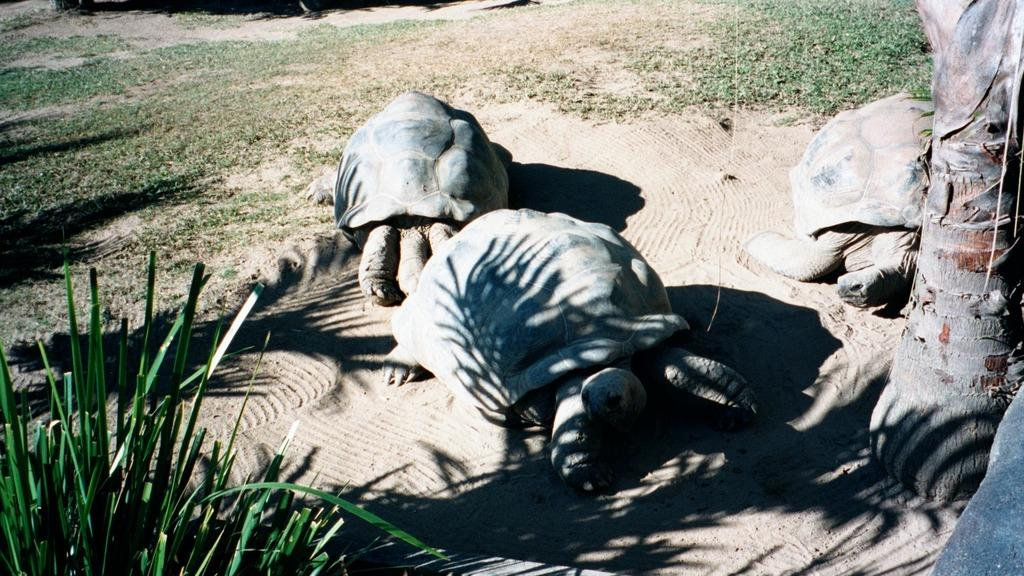What animal is present in the image? There is a tortoise in the image. What type of vegetation can be seen in the bottom left of the image? There is grass in the bottom left of the image. What part of a tree is visible on the right side of the image? There is a trunk of a tree on the right side of the image. What type of sail can be seen on the tortoise in the image? There is no sail present on the tortoise in the image. 